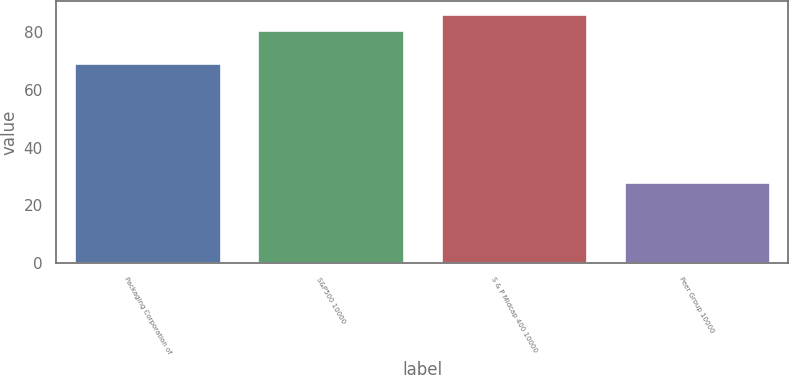Convert chart. <chart><loc_0><loc_0><loc_500><loc_500><bar_chart><fcel>Packaging Corporation of<fcel>S&P500 10000<fcel>S & P Midcap 400 10000<fcel>Peer Group 10000<nl><fcel>69.23<fcel>80.74<fcel>86.47<fcel>28.22<nl></chart> 